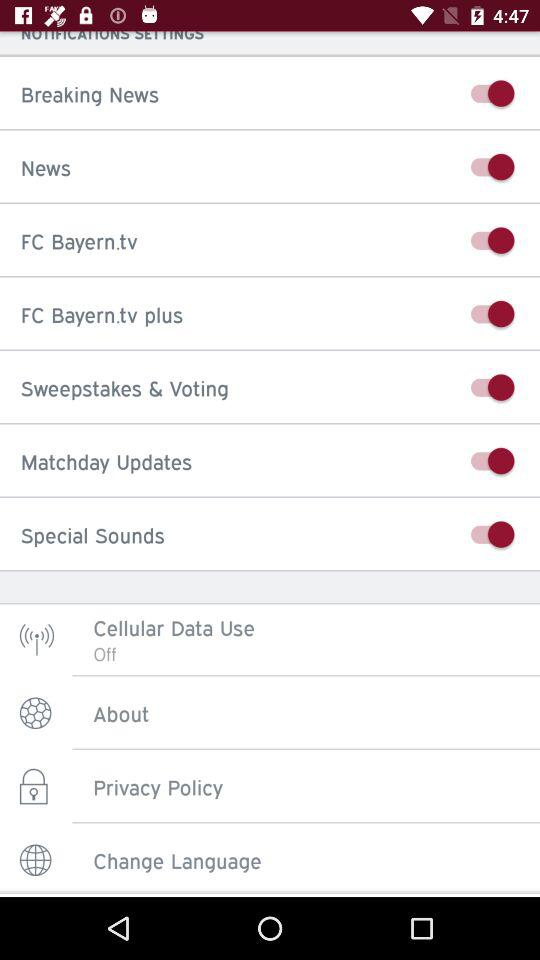What is the setting for cellular data use? The setting is "Off". 